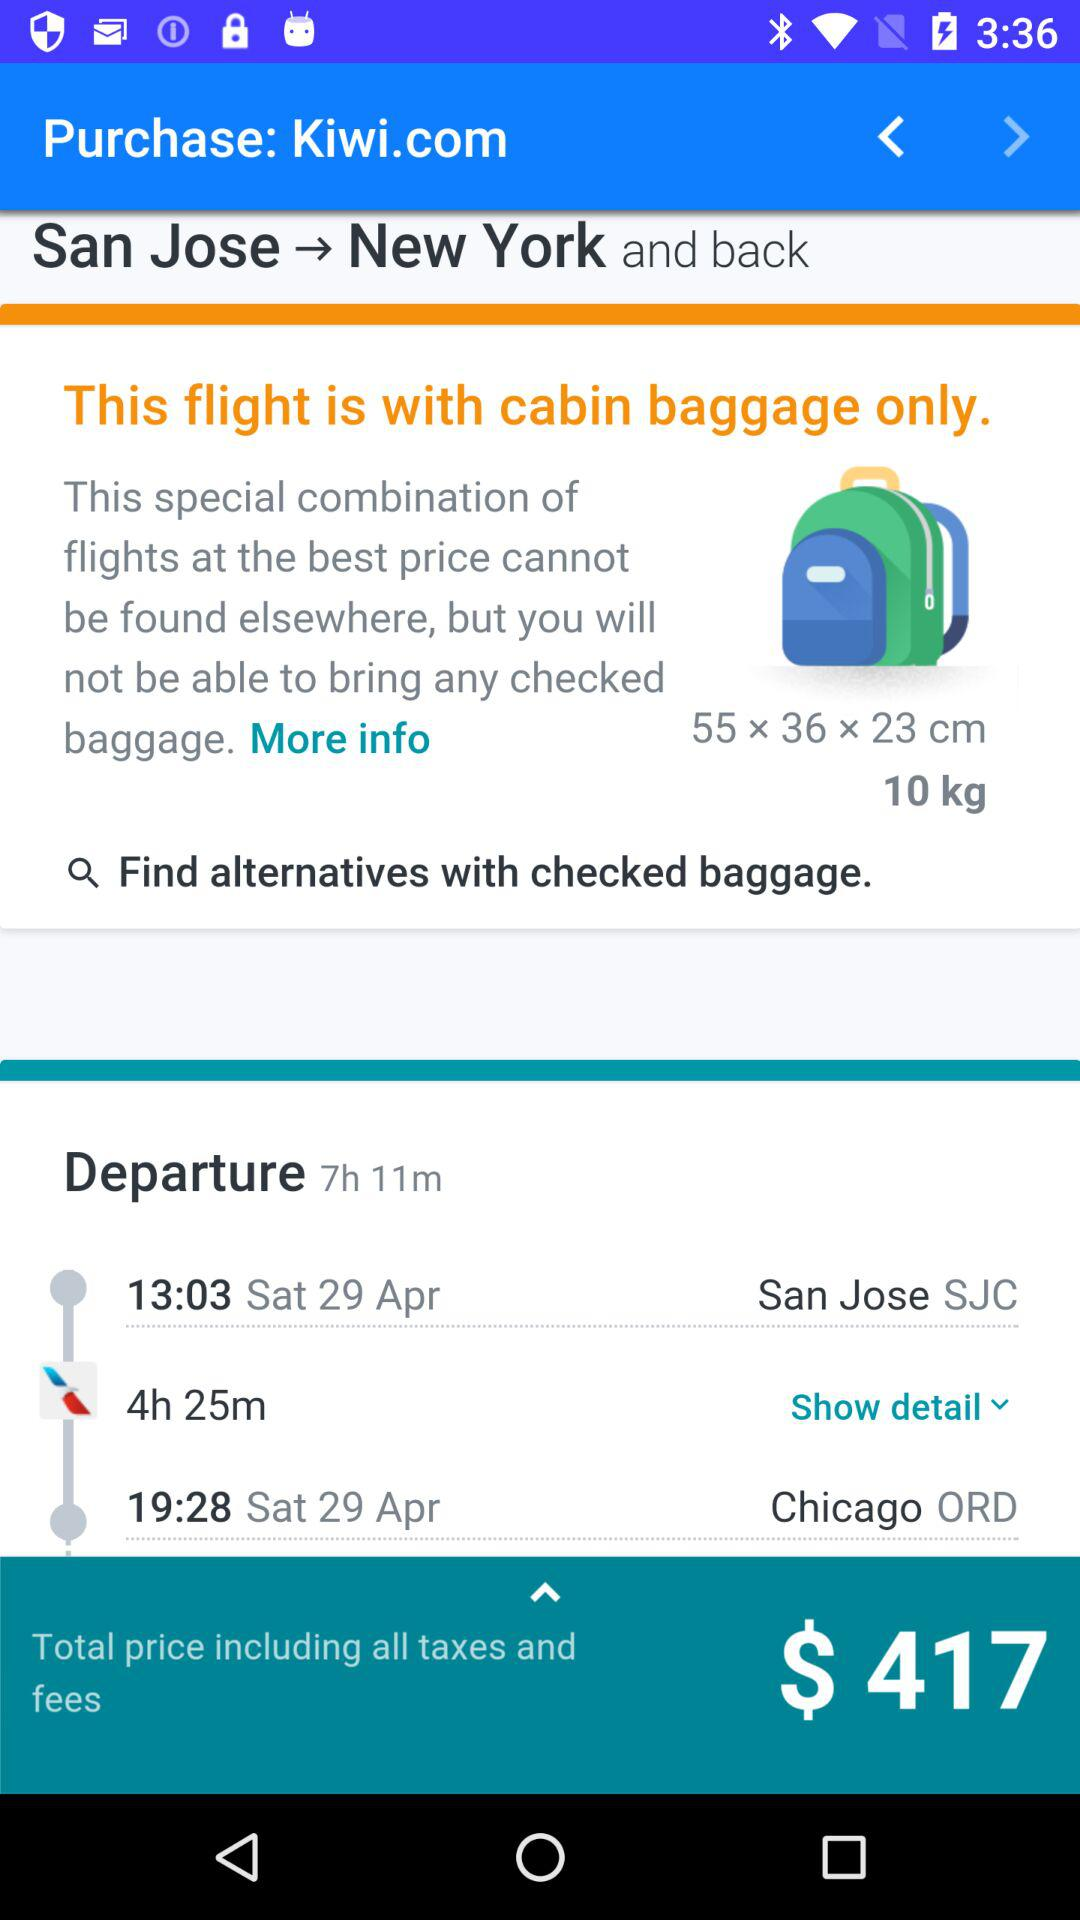What is the weight of baggage? The baggage weighs 10 kg. 